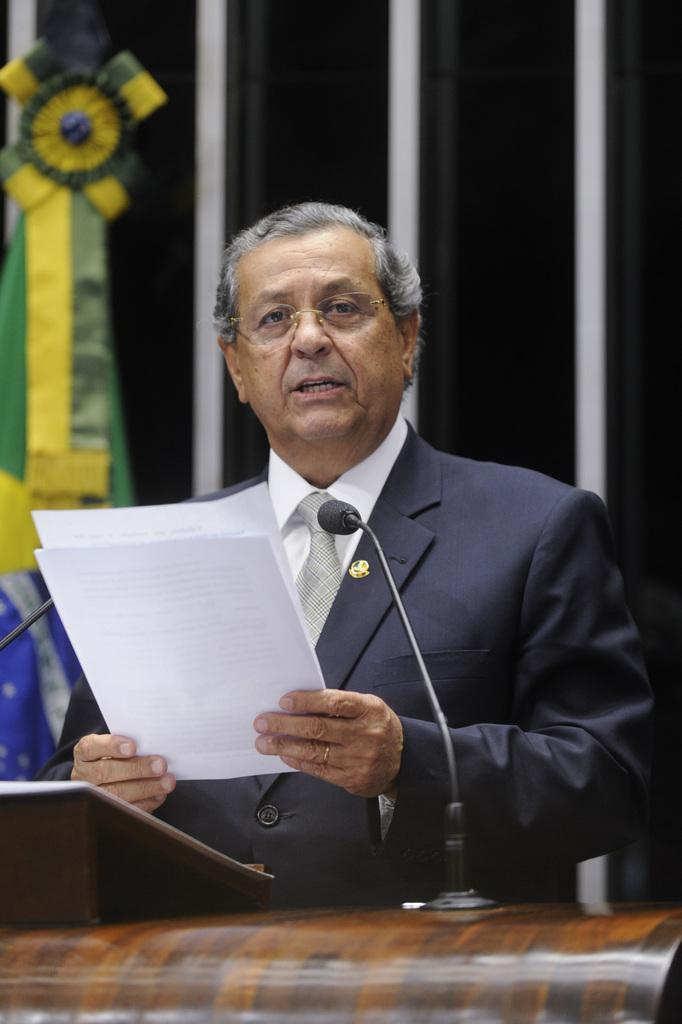Can you describe this image briefly? In the center of the image there is a person standing at the desk with the papers. In the background there is a flag and the wall. 